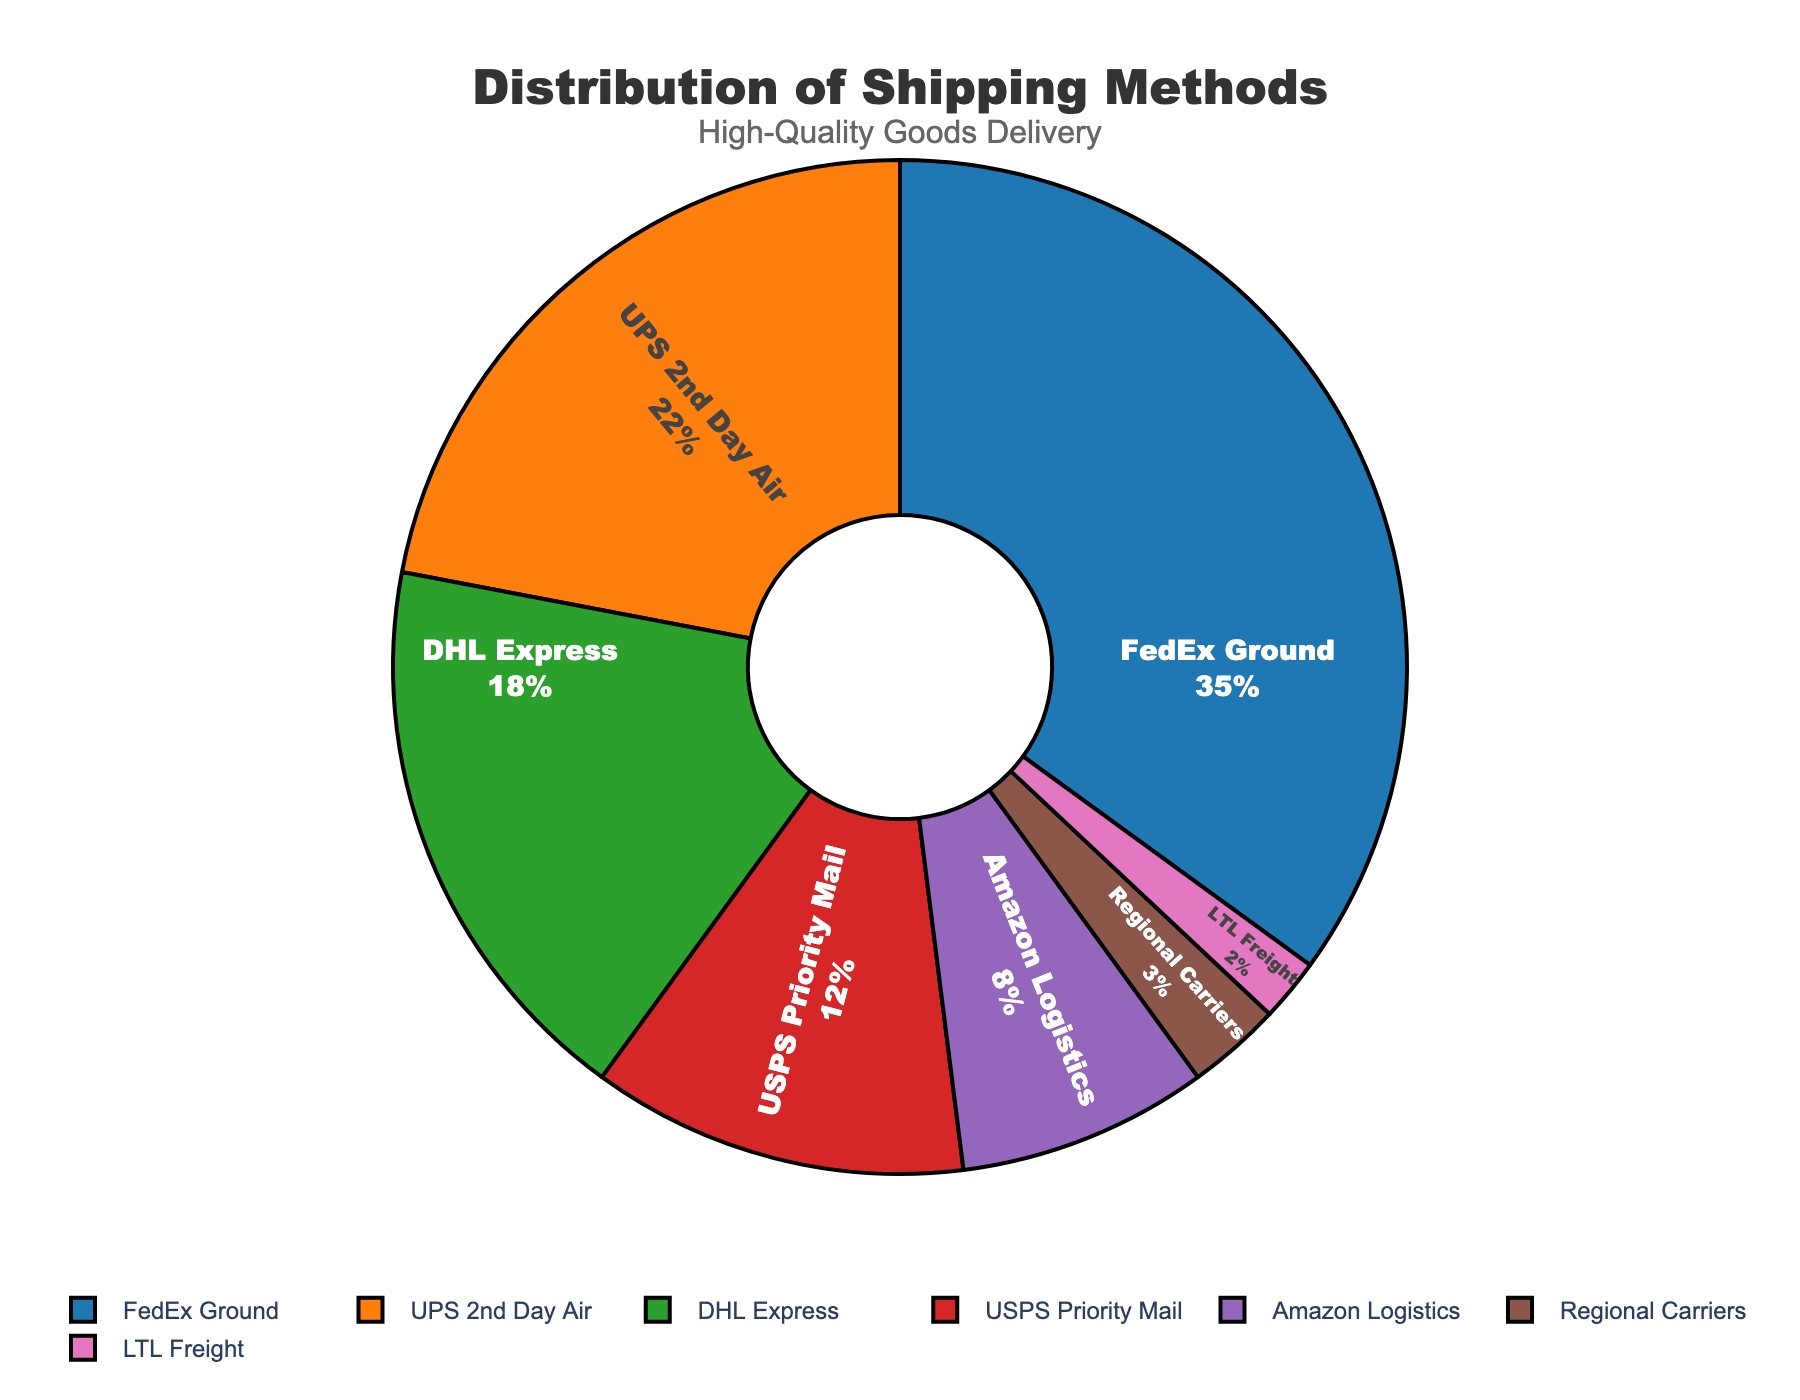How much more percentage does FedEx Ground have compared to UPS 2nd Day Air? FedEx Ground has a percentage of 35, and UPS 2nd Day Air has a percentage of 22. To find the difference: 35 - 22 = 13
Answer: 13 Which shipping method is represented by the smallest segment? The smallest percentage in the pie chart is 2%, which corresponds to LTL Freight.
Answer: LTL Freight What is the combined percentage for DHL Express and USPS Priority Mail? DHL Express has 18% and USPS Priority Mail has 12%. Their combined percentage is 18 + 12 = 30
Answer: 30 Which shipping method has the highest usage? The shipping method with the largest segment in the pie chart is FedEx Ground with 35%.
Answer: FedEx Ground Is the percentage of Amazon Logistics greater than that of Regional Carriers and LTL Freight combined? Amazon Logistics has 8%. The combined percentage of Regional Carriers and LTL Freight is 3 + 2 = 5. Since 8 > 5, Amazon Logistics has a greater percentage.
Answer: Yes How many shipping methods have a percentage greater than 10%? The methods are FedEx Ground (35%), UPS 2nd Day Air (22%), DHL Express (18%), and USPS Priority Mail (12%). Thus, 4 methods have a percentage greater than 10%.
Answer: 4 What is the ratio of the percentage of FedEx Ground to Amazon Logistics? FedEx Ground has 35% and Amazon Logistics has 8%. The ratio is 35:8.
Answer: 35:8 Which two shipping methods combined account for more than half of the total distribution? FedEx Ground (35%) and UPS 2nd Day Air (22%) together make 35 + 22 = 57, which is more than 50%.
Answer: FedEx Ground and UPS 2nd Day Air Which shipping method has the second least percentage? Regional Carriers have 3%, which is more than LTL Freight (2%) and less than Amazon Logistics (8%). Thus, Regional Carriers have the second least percentage.
Answer: Regional Carriers What is the sum of the percentages of the three least used shipping methods? The three least used are LTL Freight (2%), Regional Carriers (3%), and Amazon Logistics (8%). Their sum is 2 + 3 + 8 = 13%.
Answer: 13 